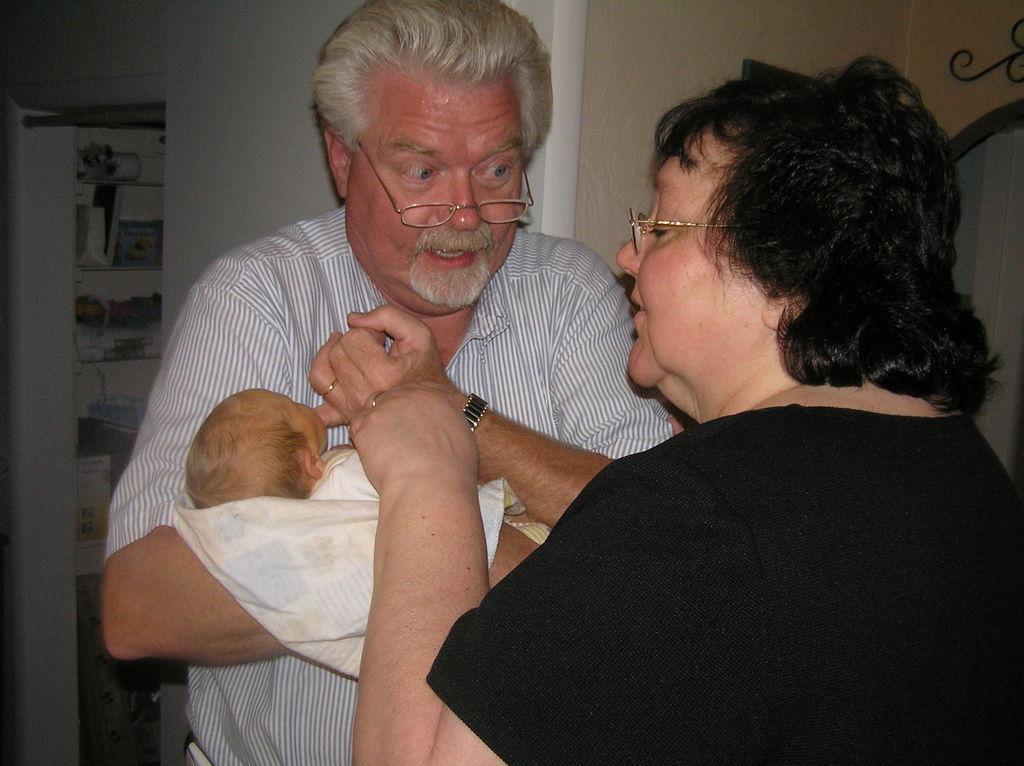Describe this image in one or two sentences. In the given picture, I can see three people and there is a old men who is wearing a specs and holding a small baby so right opposite to a men there is a women. Who is standing and wearing a black color t shirt and watching a kid and behind this people. I can see a wall and few objects. 